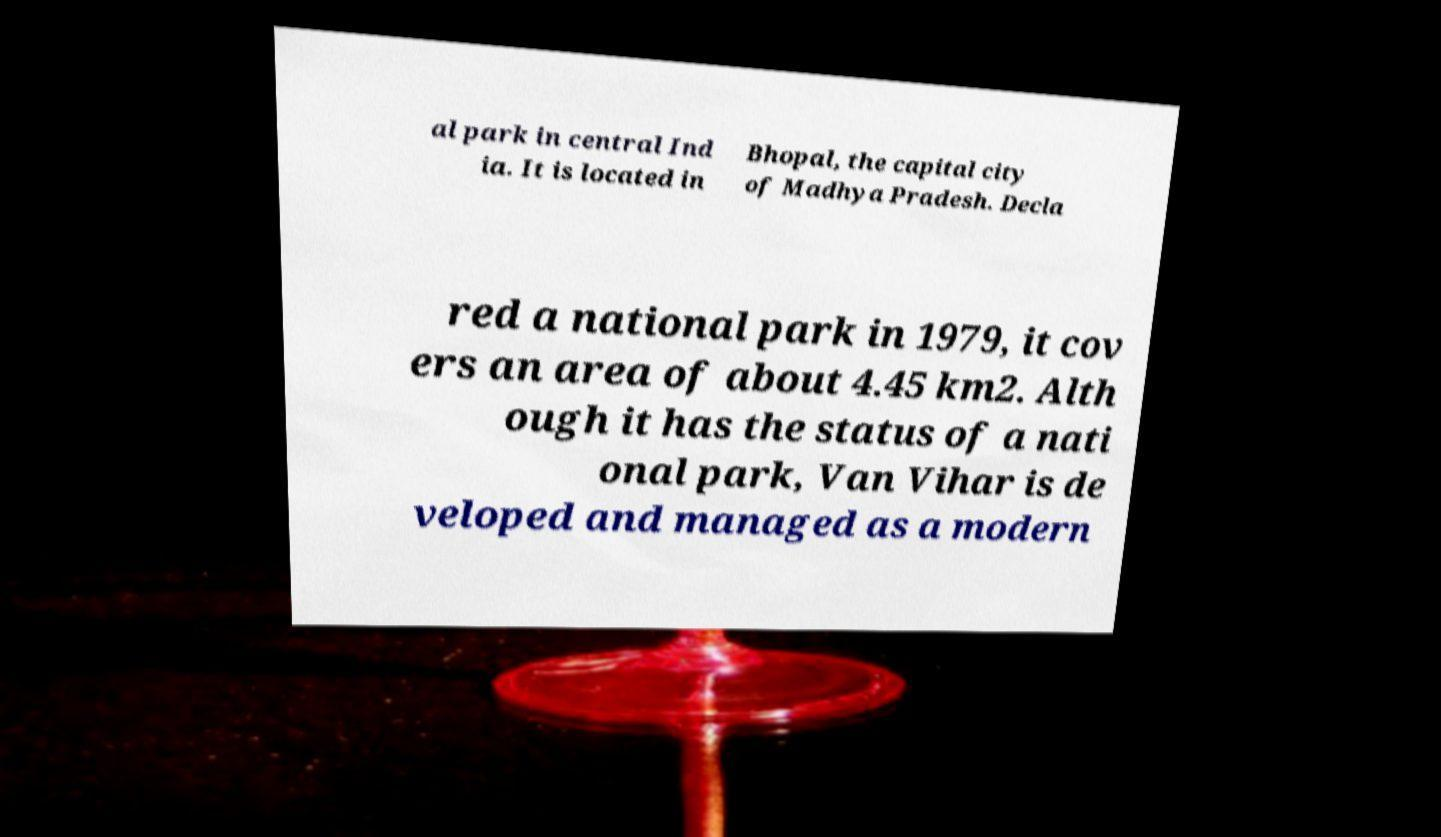Please read and relay the text visible in this image. What does it say? al park in central Ind ia. It is located in Bhopal, the capital city of Madhya Pradesh. Decla red a national park in 1979, it cov ers an area of about 4.45 km2. Alth ough it has the status of a nati onal park, Van Vihar is de veloped and managed as a modern 